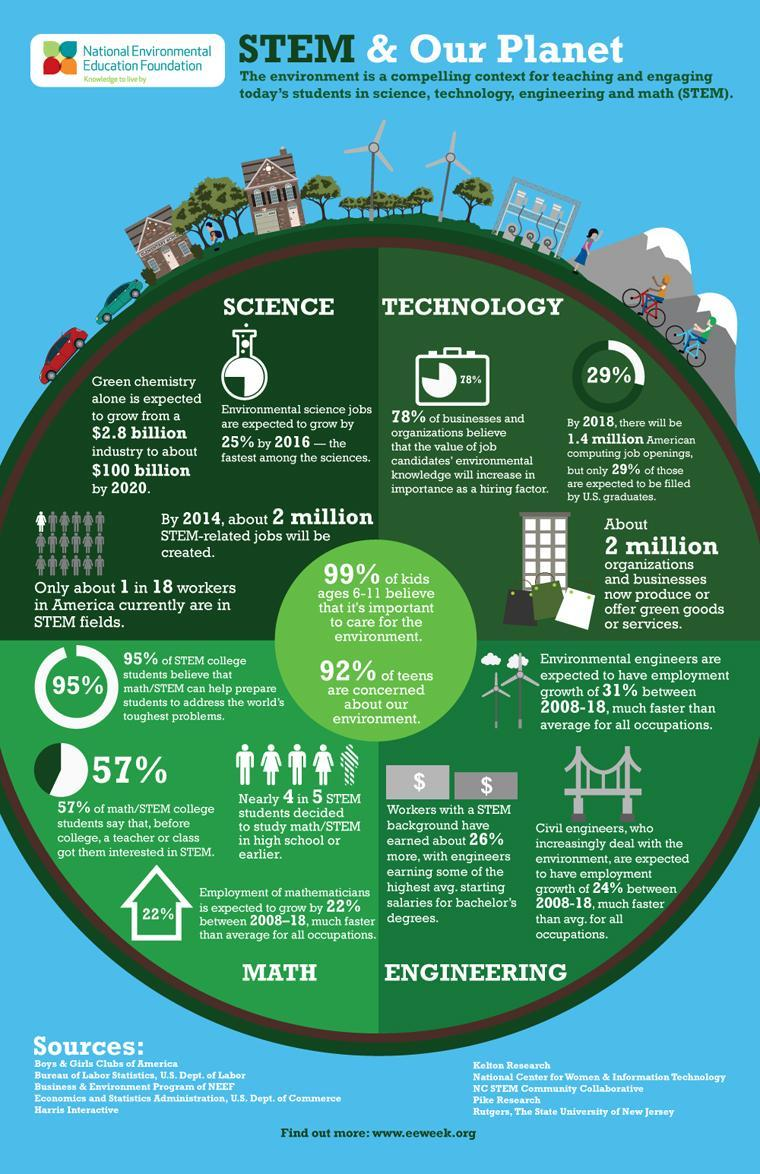How many streams does STEM deal with ?
Answer the question with a short phrase. 4 What percentage of computing job openings will be held by non US students? 71% What is percentage of kids that feel that they need not care for the environment? 1% 